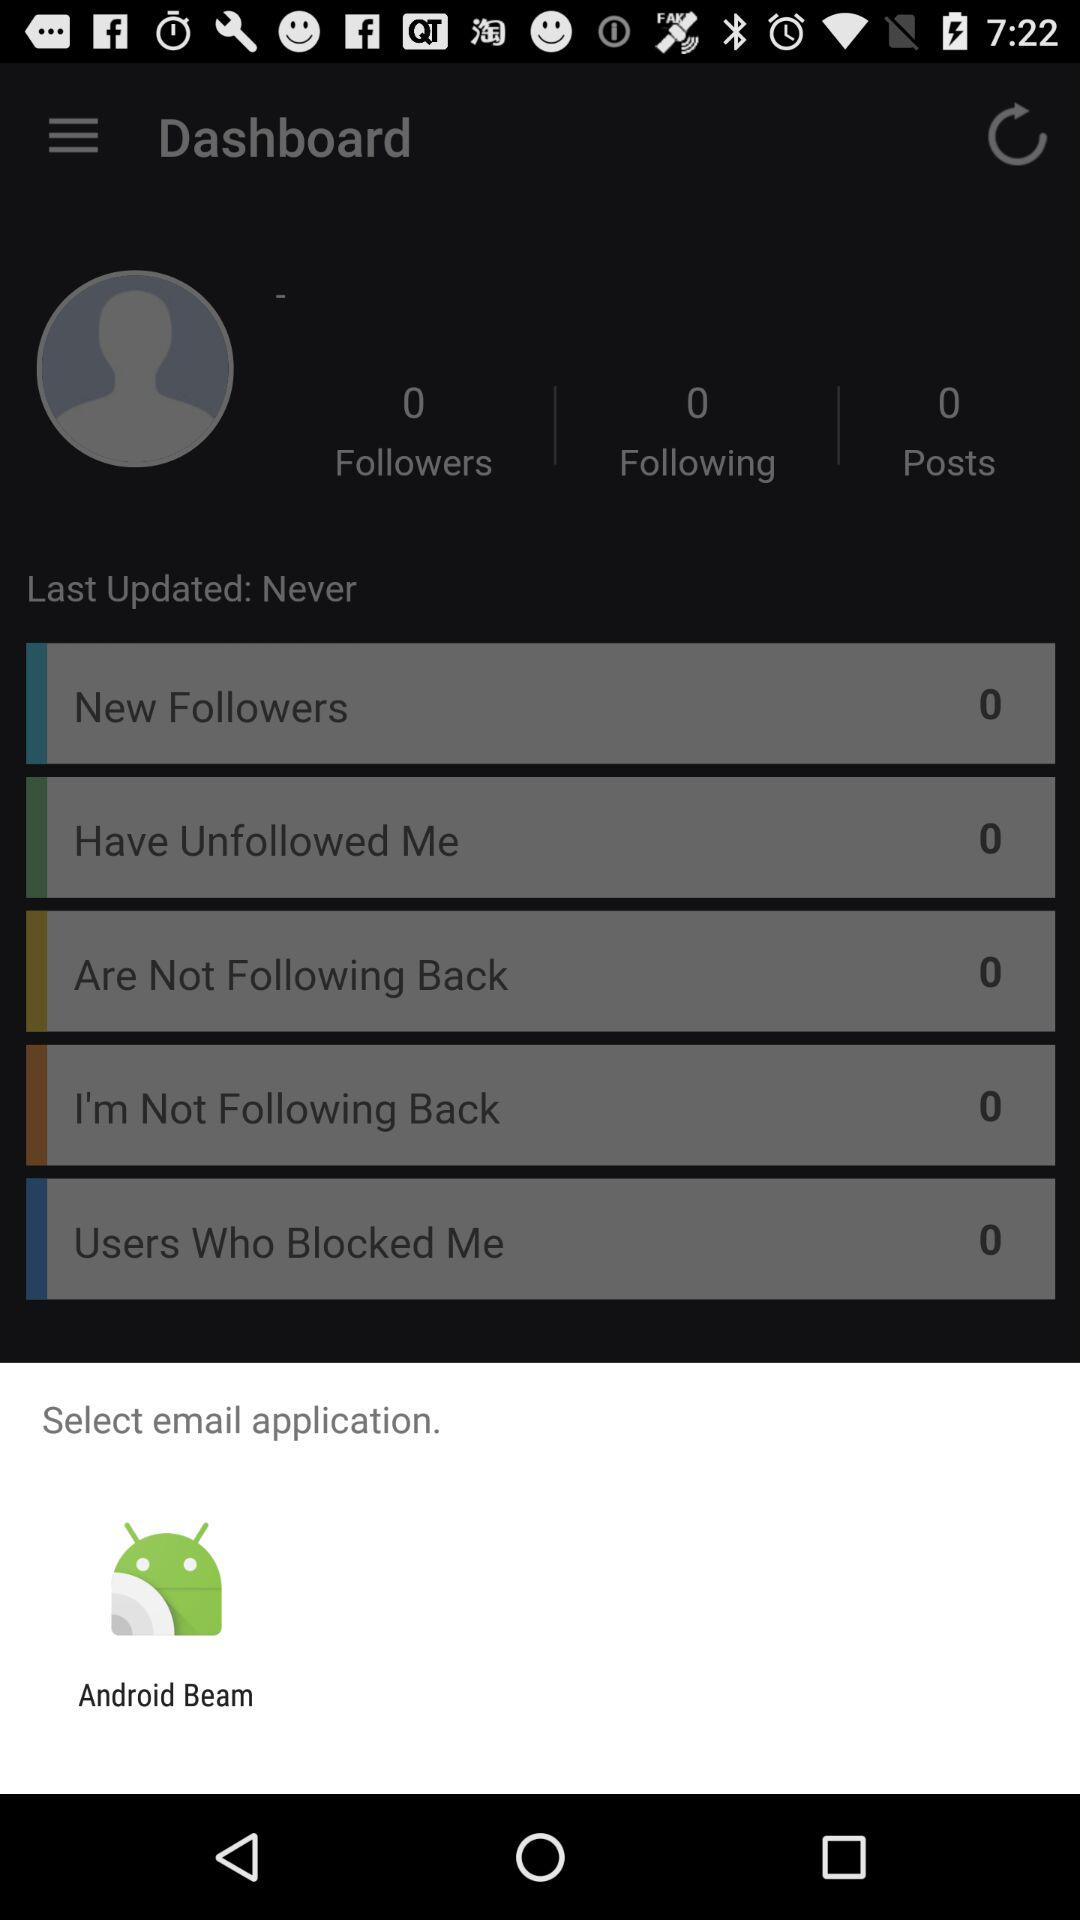How many people does the user follow? The user follows 0 people. 